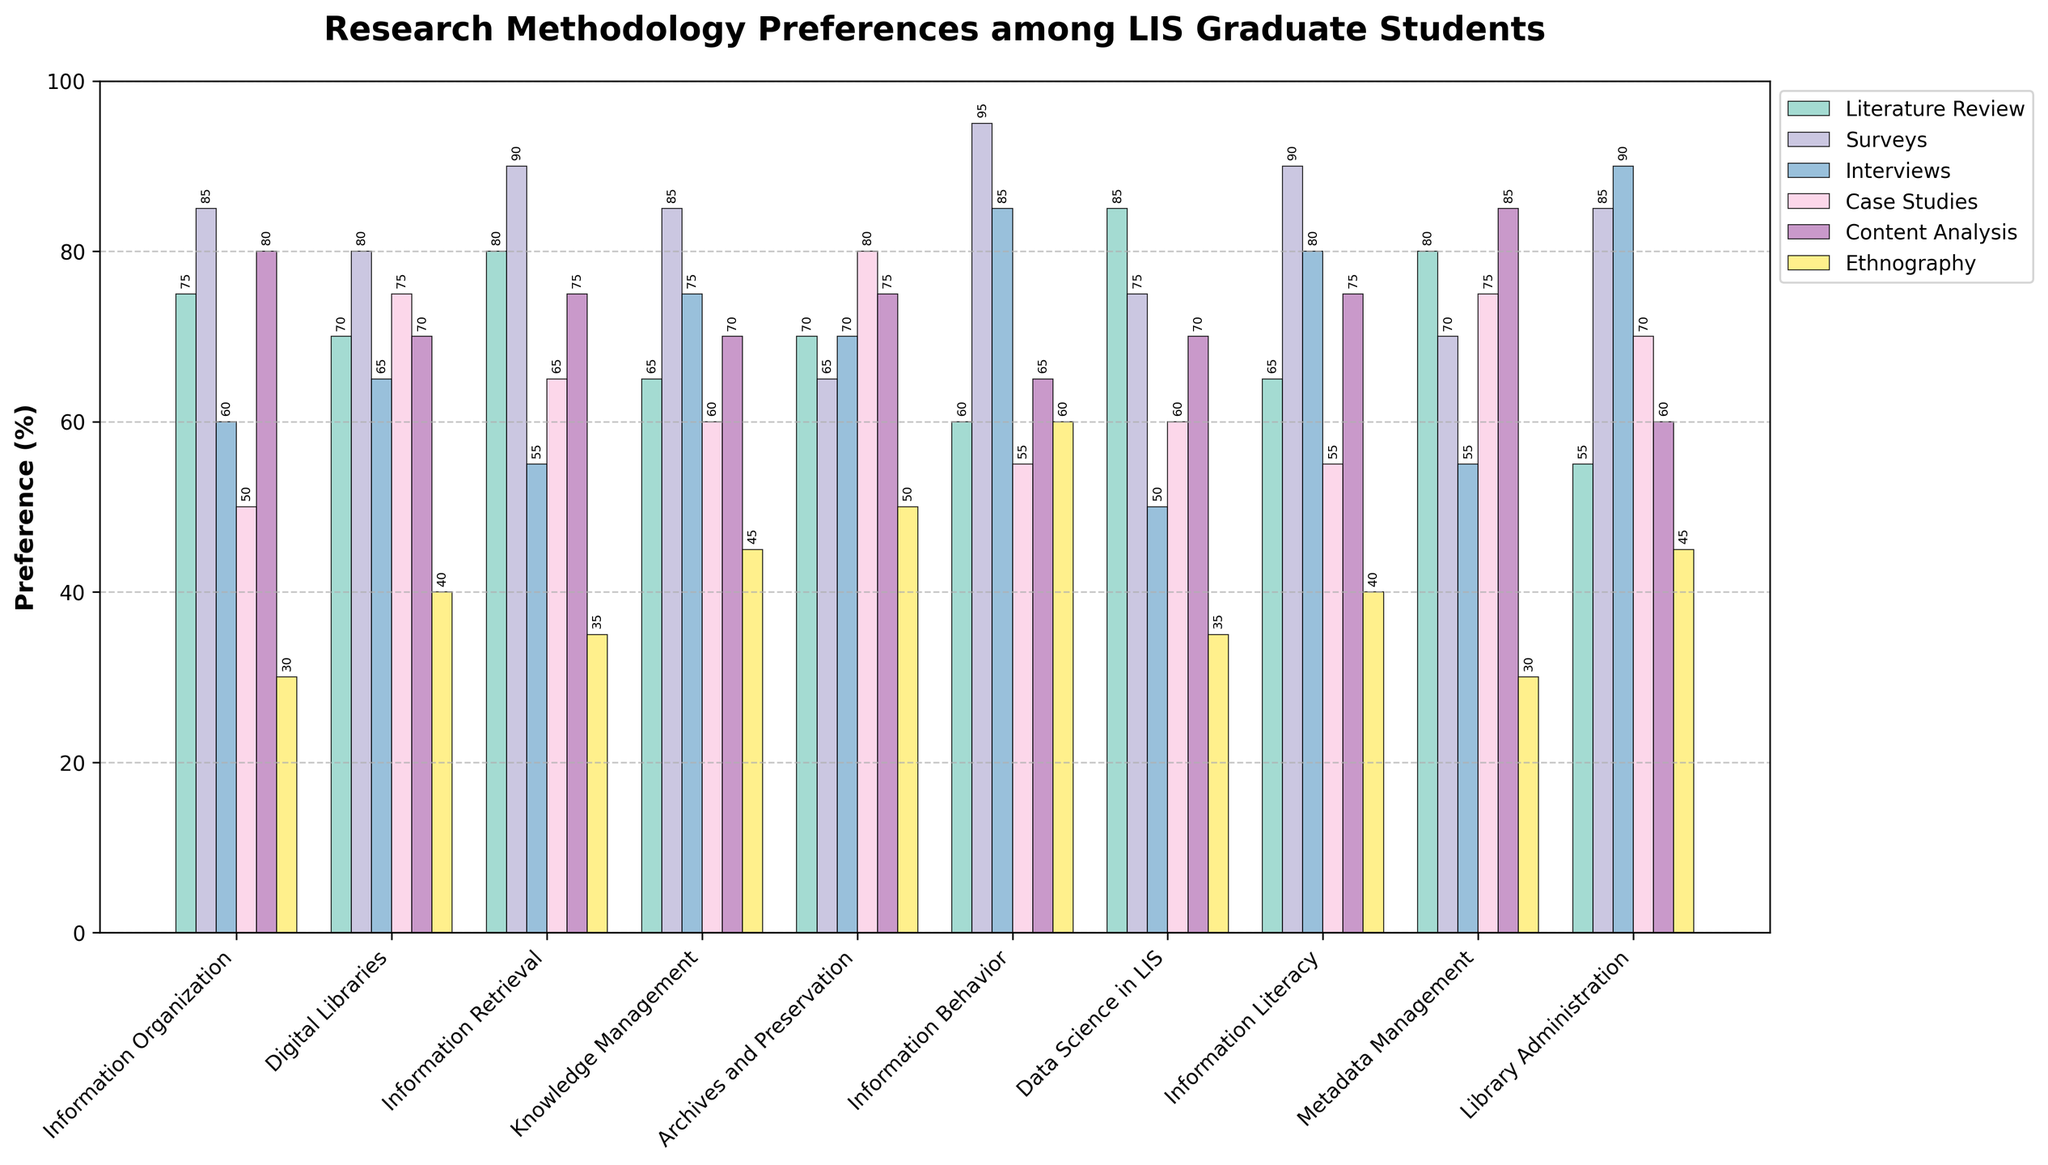Which specialization shows the highest preference for interviews? To determine the highest preference for interviews, look at the height of the bars representing "Interviews" for all specializations. The specialization with the tallest bar is Library Administration with a preference percentage of 90.
Answer: Library Administration Which research method is least preferred by the Information Organization specialization? To find the least preferred research method, compare the heights of all the bars for the Information Organization specialization. The smallest bar corresponds to Ethnography with a preference percentage of 30.
Answer: Ethnography What's the total preference score for Content Analysis across all specializations? Add the percentages for Content Analysis from all the specializations: 80 (Information Organization) + 70 (Digital Libraries) + 75 (Information Retrieval) + 70 (Knowledge Management) + 75 (Archives and Preservation) + 65 (Information Behavior) + 70 (Data Science in LIS) + 75 (Information Literacy) + 85 (Metadata Management) + 60 (Library Administration) = 725.
Answer: 725 Which specializations prefer Literature Reviews over Surveys? Compare the heights of the bars for Literature Review and Surveys within each specialization to identify which ones have higher Literature Review bars than Surveys bars. The specializations where Literature Review is preferred over Surveys are Metadata Management (80 > 70) and Data Science in LIS (85 > 75).
Answer: Metadata Management, Data Science in LIS Which specialization has the lowest average preference score across all research methods? Calculate the average preference score for each specialization and identify the lowest. For Information Organization: (75 + 85 + 60 + 50 + 80 + 30)/6 = 63.33. Repeat for all and compare: Information Organization: 63.33, Digital Libraries: 66.67, Information Retrieval: 65.00, Knowledge Management: 66.67, Archives and Preservation: 68.33, Information Behavior: 70.00, Data Science in LIS: 62.50, Information Literacy: 67.50, Metadata Management: 65.83, Library Administration: 67.50. The lowest is Data Science in LIS.
Answer: Data Science in LIS 